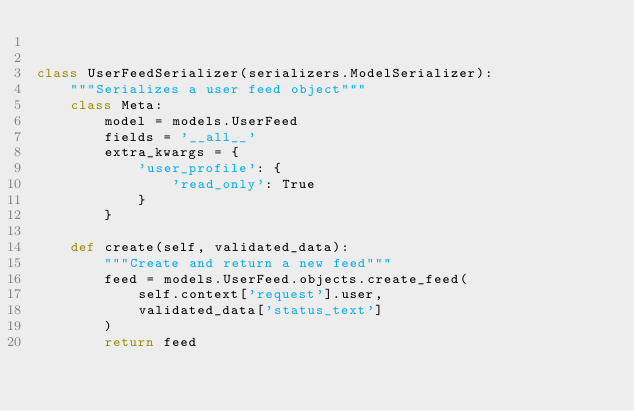Convert code to text. <code><loc_0><loc_0><loc_500><loc_500><_Python_>

class UserFeedSerializer(serializers.ModelSerializer):
    """Serializes a user feed object"""
    class Meta:
        model = models.UserFeed
        fields = '__all__'
        extra_kwargs = {
            'user_profile': {
                'read_only': True
            }
        }

    def create(self, validated_data):
        """Create and return a new feed"""
        feed = models.UserFeed.objects.create_feed(
            self.context['request'].user,
            validated_data['status_text']
        )
        return feed
</code> 